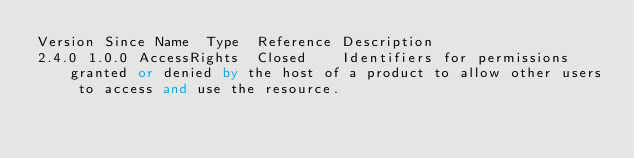Convert code to text. <code><loc_0><loc_0><loc_500><loc_500><_SQL_>Version	Since	Name	Type	Reference	Description
2.4.0	1.0.0	AccessRights	Closed		Identifiers for permissions granted or denied by the host of a product to allow other users to access and use the resource.</code> 